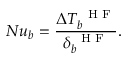Convert formula to latex. <formula><loc_0><loc_0><loc_500><loc_500>N u _ { b } = \frac { \Delta T _ { b } ^ { H F } } { \delta _ { b } ^ { H F } } .</formula> 